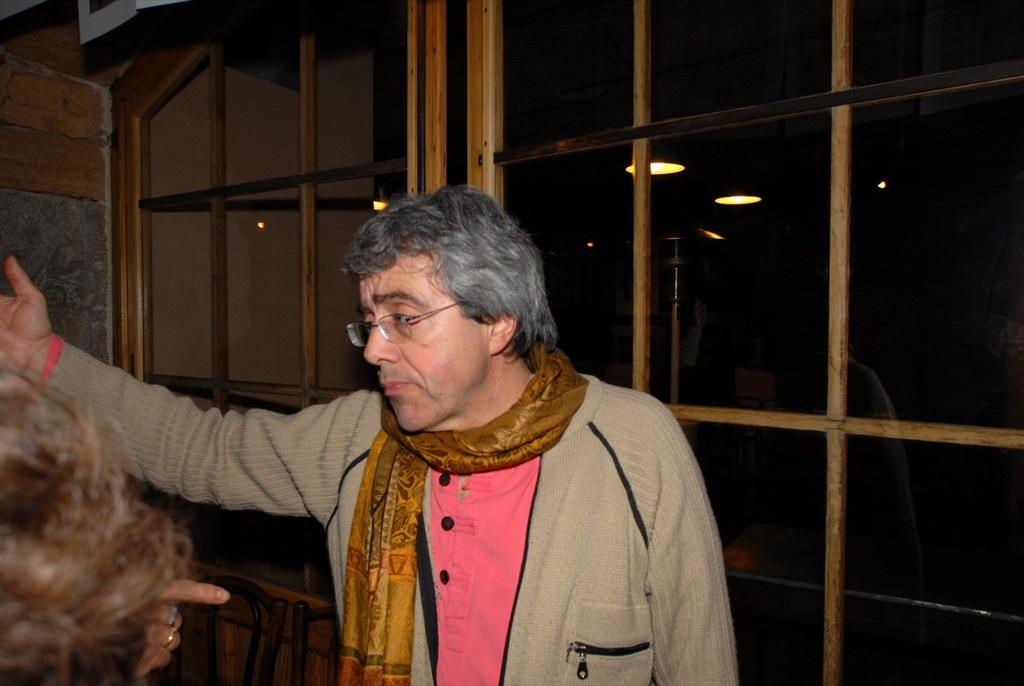What is the main subject of the image? There is a person standing in the middle of the image. Can you describe the background of the image? There is a door in the background of the image. Is the person in the image being attacked by steam? There is no steam present in the image, and therefore no such attack can be observed. 